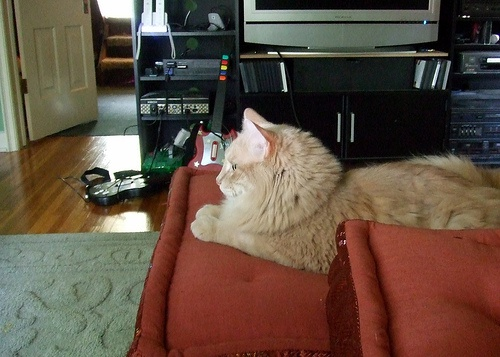Describe the objects in this image and their specific colors. I can see couch in gray, maroon, and brown tones, cat in gray and tan tones, and tv in gray, black, and darkgray tones in this image. 